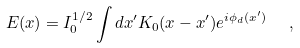Convert formula to latex. <formula><loc_0><loc_0><loc_500><loc_500>E ( x ) = I _ { 0 } ^ { 1 / 2 } \int d x ^ { \prime } K _ { 0 } ( x - x ^ { \prime } ) e ^ { i \phi _ { d } ( x ^ { \prime } ) } \ \ ,</formula> 